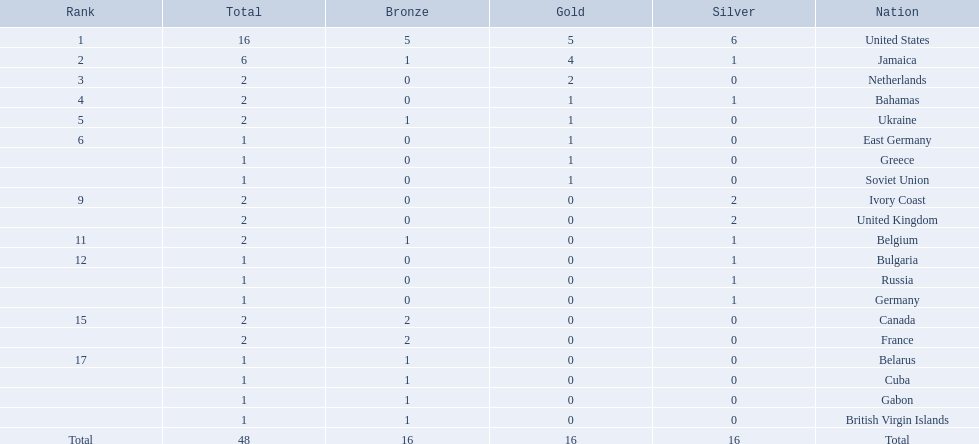Which nations took home at least one gold medal in the 60 metres competition? United States, Jamaica, Netherlands, Bahamas, Ukraine, East Germany, Greece, Soviet Union. Of these nations, which one won the most gold medals? United States. 